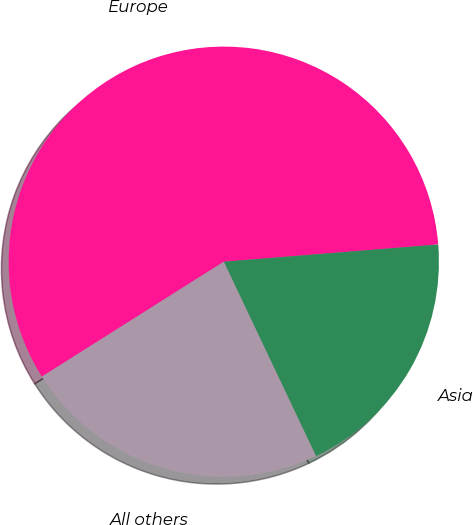Convert chart to OTSL. <chart><loc_0><loc_0><loc_500><loc_500><pie_chart><fcel>Europe<fcel>Asia<fcel>All others<nl><fcel>57.69%<fcel>19.23%<fcel>23.08%<nl></chart> 